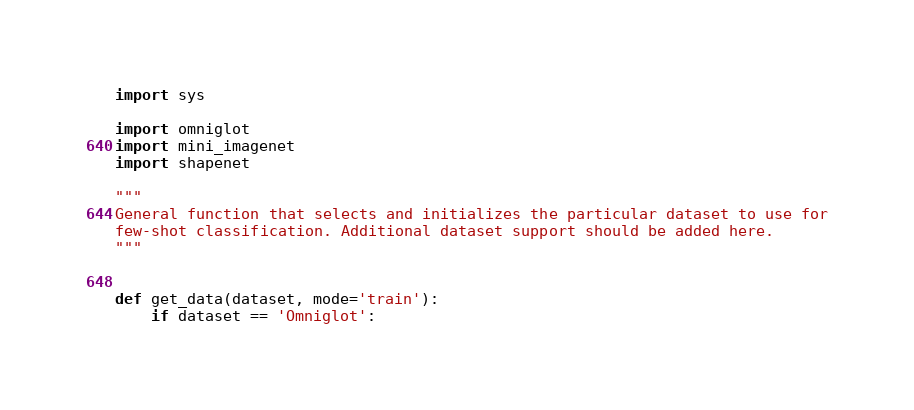<code> <loc_0><loc_0><loc_500><loc_500><_Python_>import sys

import omniglot
import mini_imagenet
import shapenet

"""
General function that selects and initializes the particular dataset to use for
few-shot classification. Additional dataset support should be added here.
"""


def get_data(dataset, mode='train'):
    if dataset == 'Omniglot':</code> 